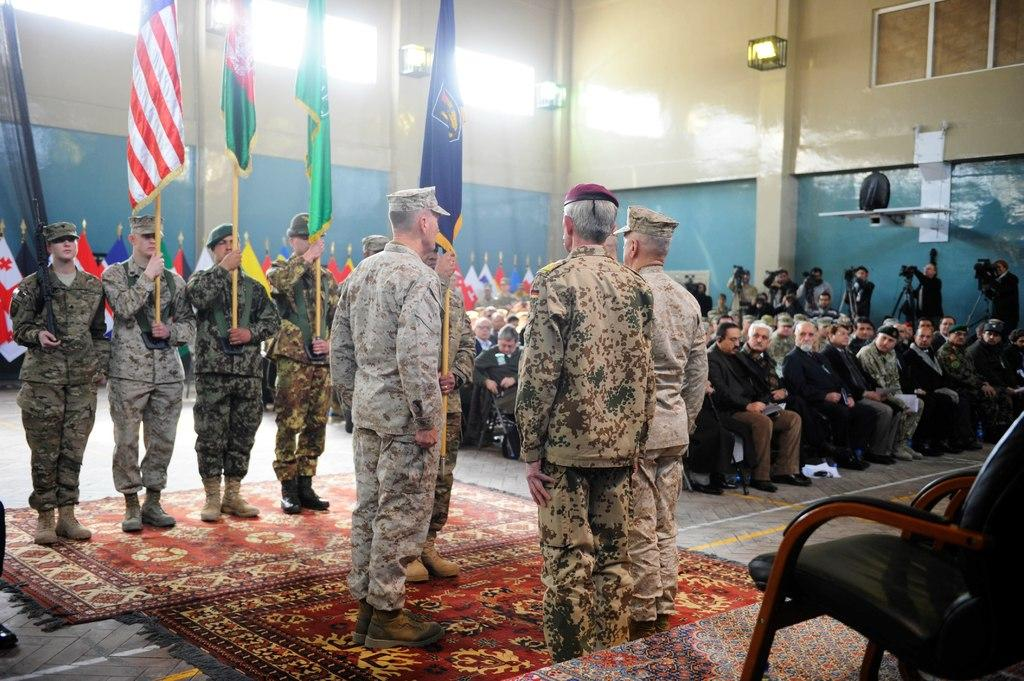How many people are in the image? There is a group of people in the image, but the exact number is not specified. What are some people doing in the image? Some people are sitting on chairs, and some are holding flags. Are there any chairs that are not occupied in the image? Yes, there are additional chairs in the image. Can you see a giraffe in the image? No, there is no giraffe present in the image. What type of tree is visible in the image? There is no tree visible in the image. 